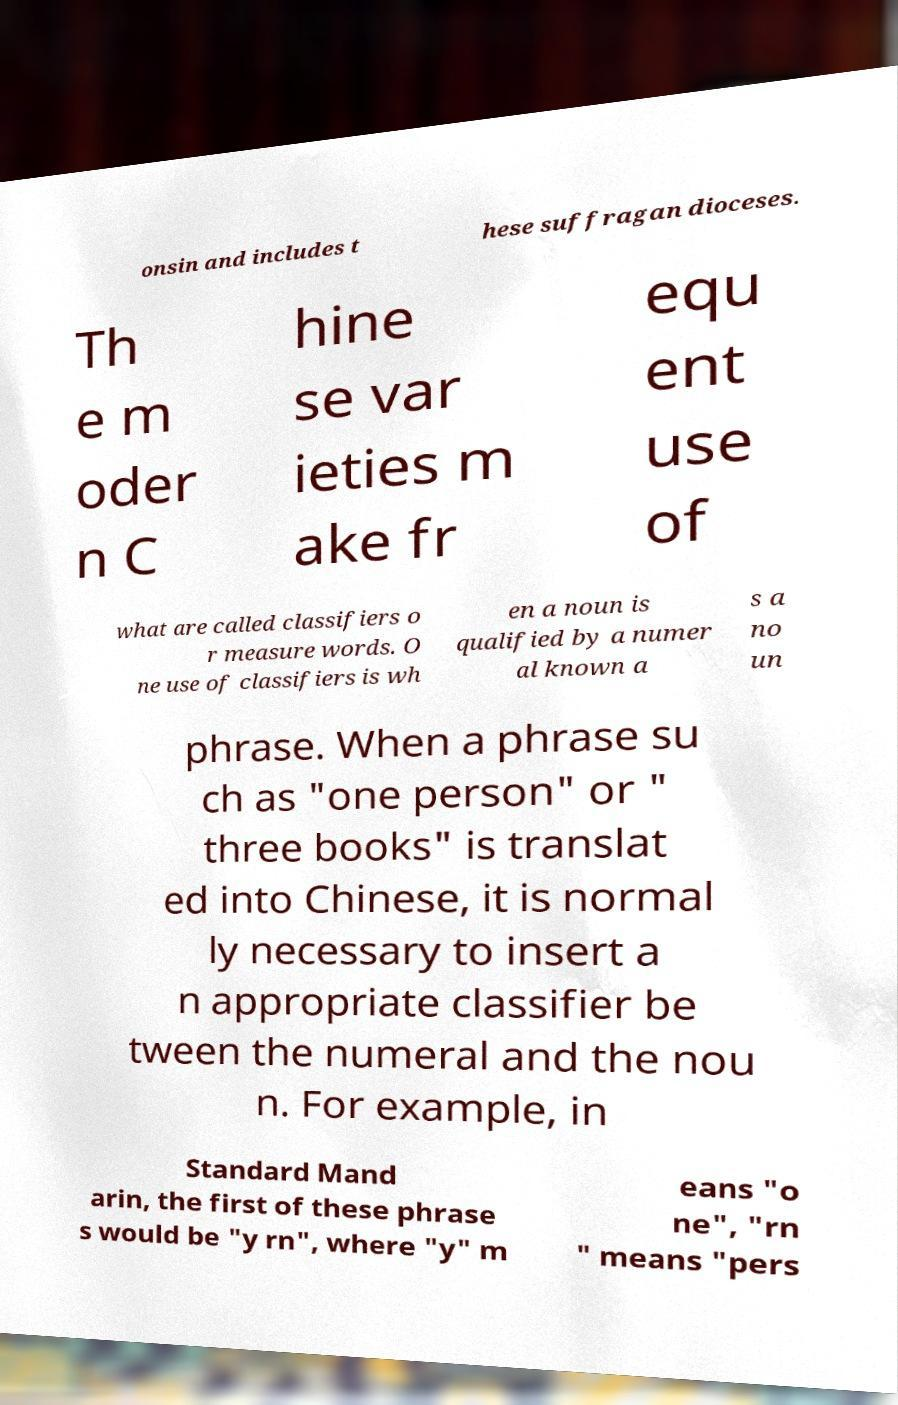What messages or text are displayed in this image? I need them in a readable, typed format. onsin and includes t hese suffragan dioceses. Th e m oder n C hine se var ieties m ake fr equ ent use of what are called classifiers o r measure words. O ne use of classifiers is wh en a noun is qualified by a numer al known a s a no un phrase. When a phrase su ch as "one person" or " three books" is translat ed into Chinese, it is normal ly necessary to insert a n appropriate classifier be tween the numeral and the nou n. For example, in Standard Mand arin, the first of these phrase s would be "y rn", where "y" m eans "o ne", "rn " means "pers 